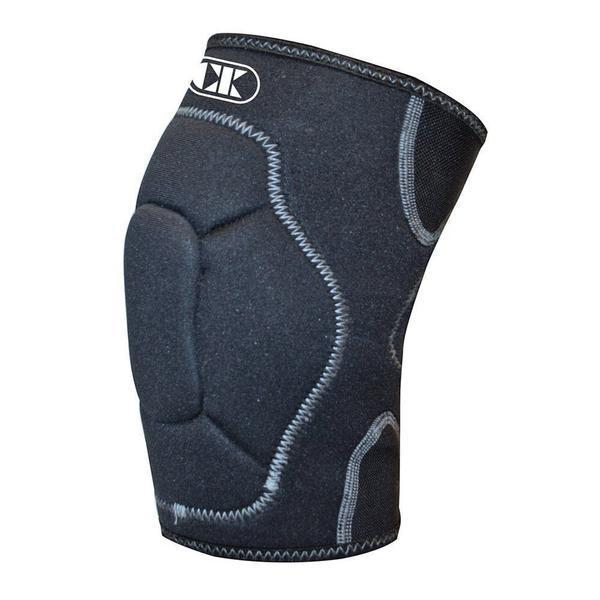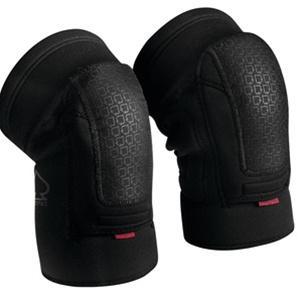The first image is the image on the left, the second image is the image on the right. Analyze the images presented: Is the assertion "There are two kneepads in total" valid? Answer yes or no. No. 